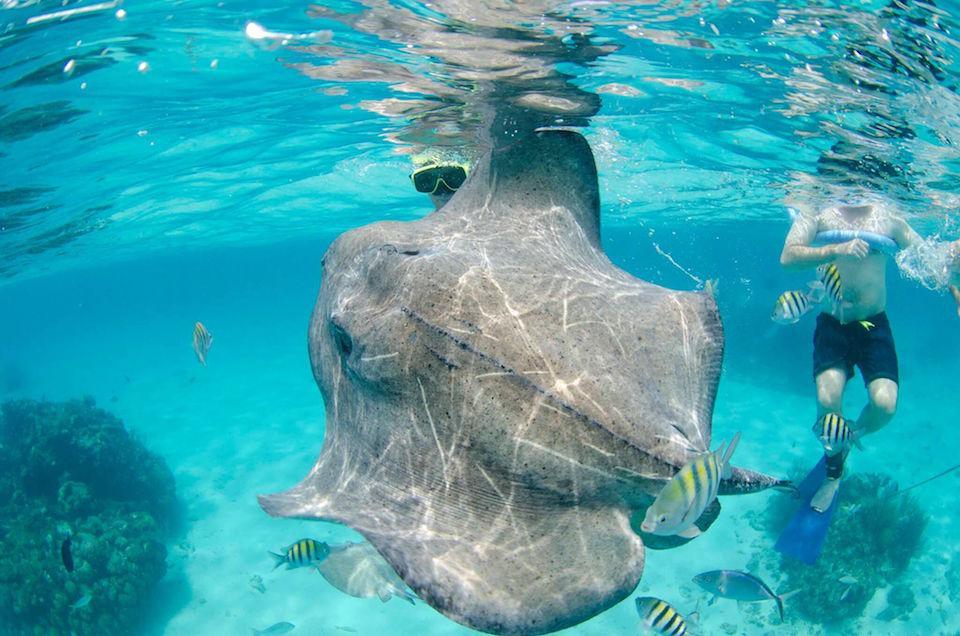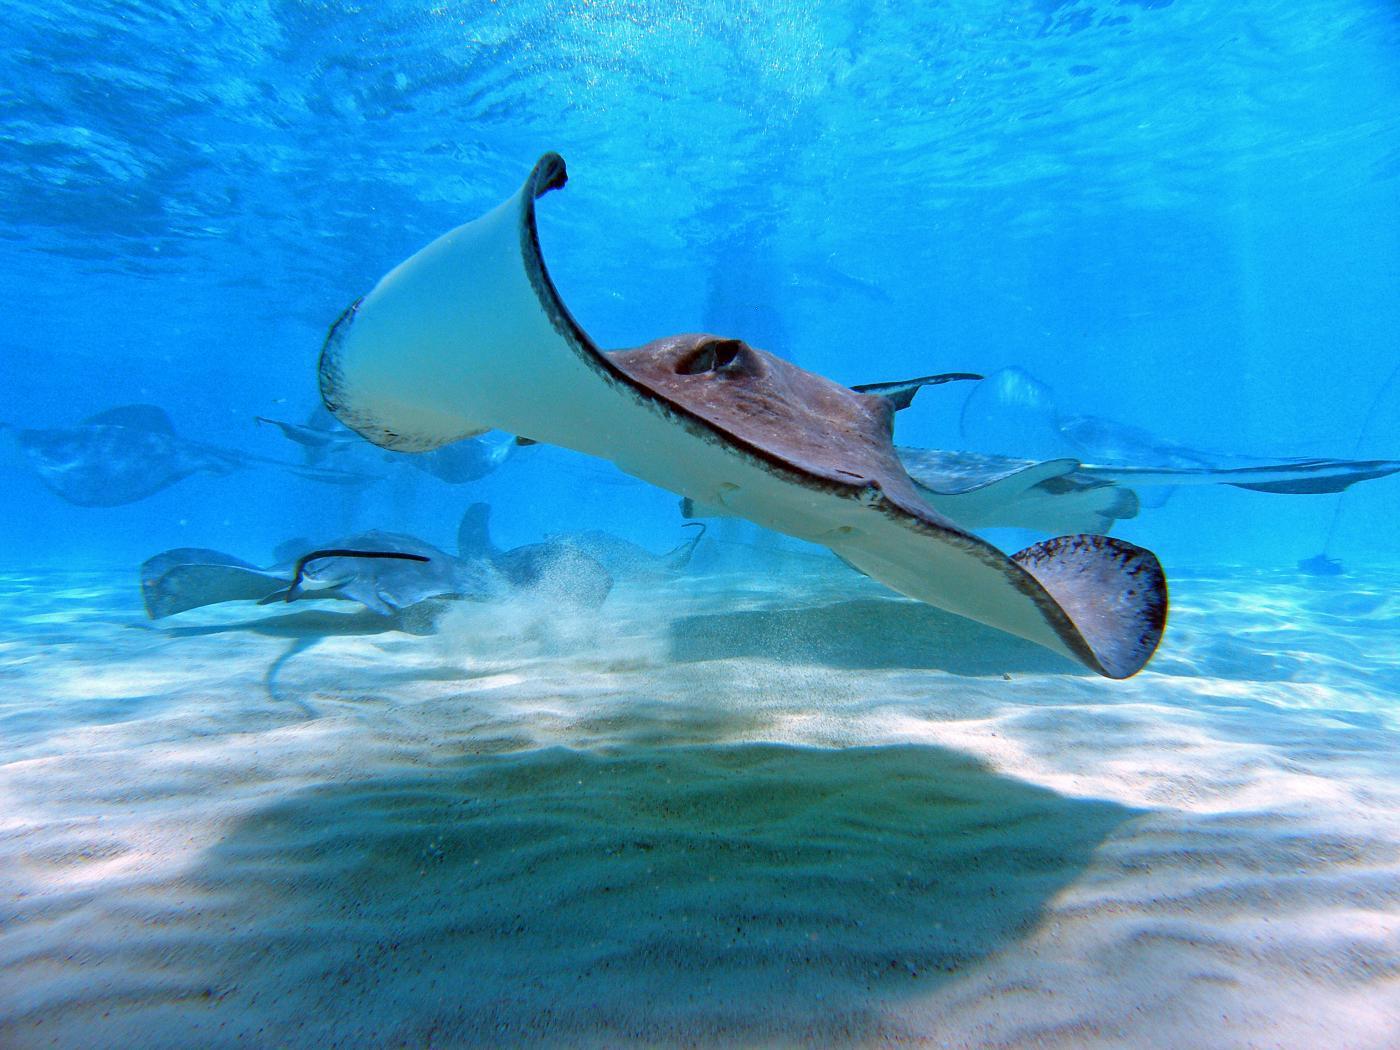The first image is the image on the left, the second image is the image on the right. Considering the images on both sides, is "There is at least one person snorkeling in the water near one or more sting rays" valid? Answer yes or no. Yes. The first image is the image on the left, the second image is the image on the right. Analyze the images presented: Is the assertion "There is one human in the left image." valid? Answer yes or no. Yes. 